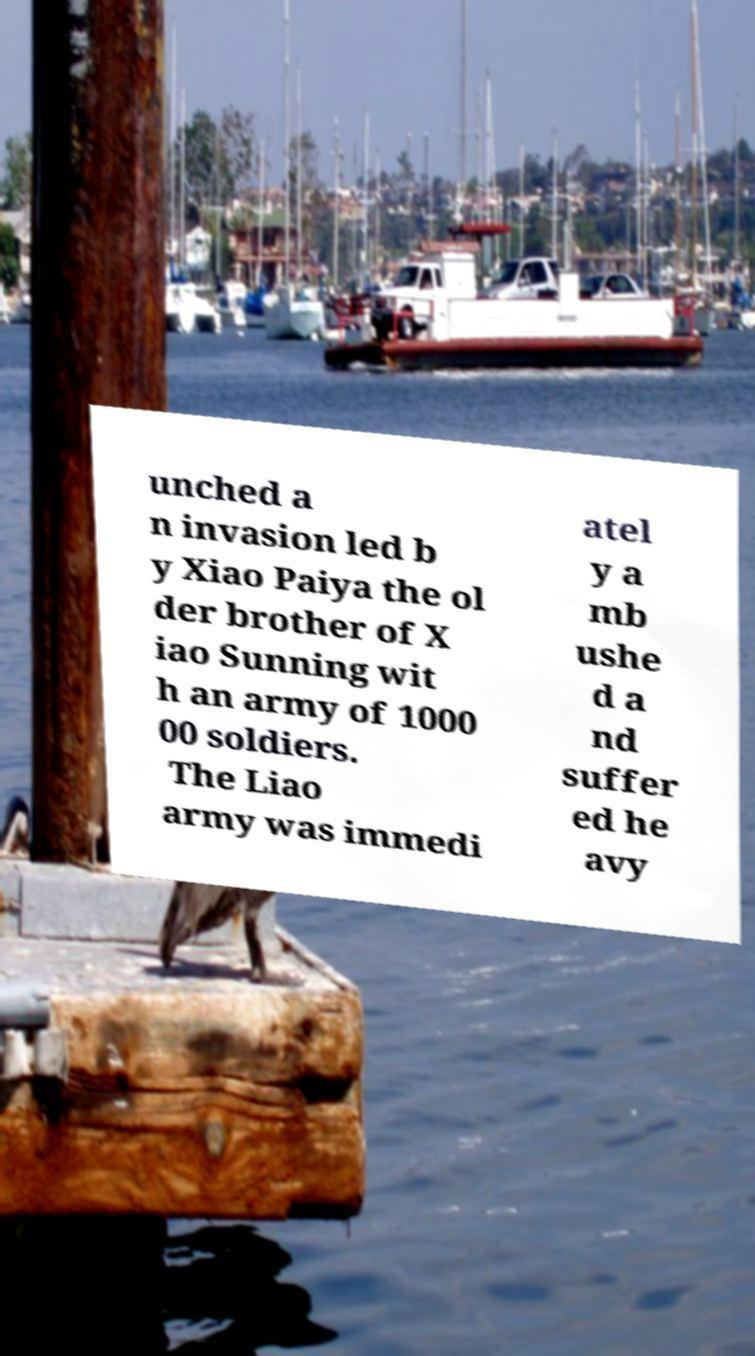Can you accurately transcribe the text from the provided image for me? unched a n invasion led b y Xiao Paiya the ol der brother of X iao Sunning wit h an army of 1000 00 soldiers. The Liao army was immedi atel y a mb ushe d a nd suffer ed he avy 